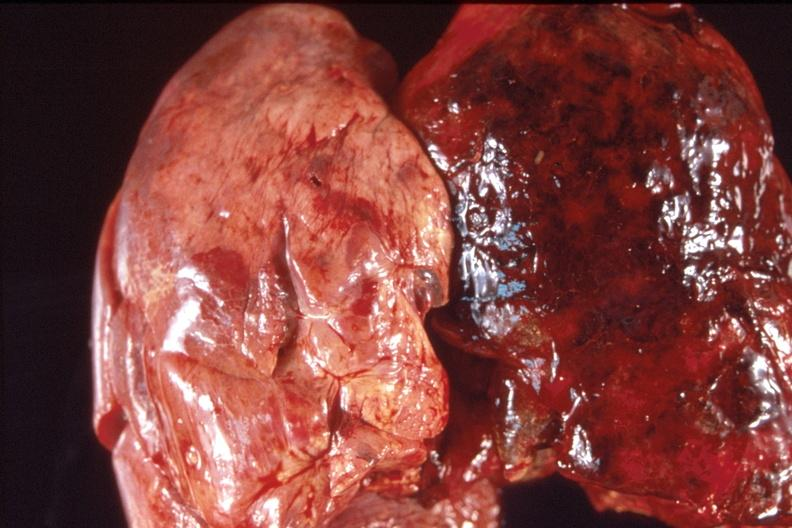s respiratory present?
Answer the question using a single word or phrase. Yes 